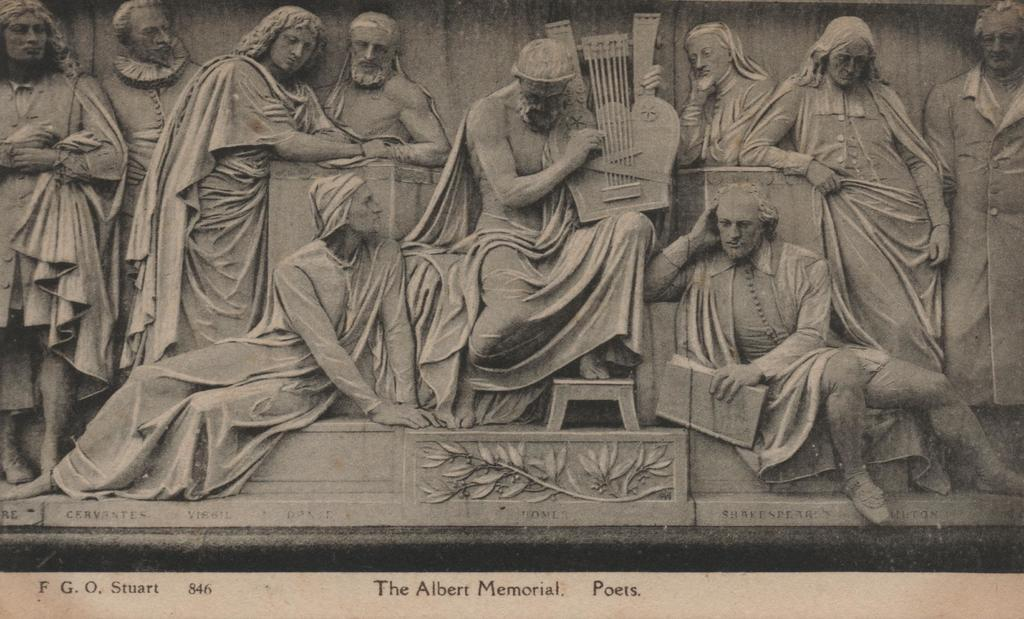What is the main subject of the picture? The main subject of the picture is a sculpture. What does the sculpture depict? The sculpture depicts multiple persons. Is there any text associated with the sculpture in the picture? Yes, there is text written below the sculpture. What type of farming equipment can be seen in the hands of the persons depicted in the sculpture? There is no farming equipment visible in the sculpture; it depicts multiple persons without any specific tools or objects. 